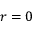<formula> <loc_0><loc_0><loc_500><loc_500>r = 0</formula> 